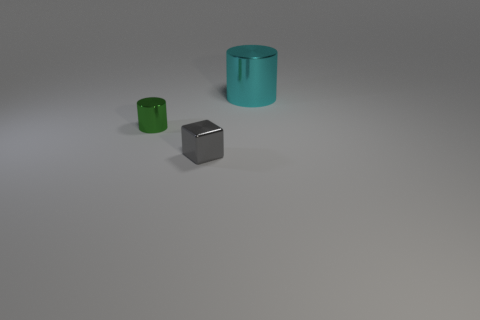Add 1 tiny shiny objects. How many objects exist? 4 Subtract all blocks. How many objects are left? 2 Add 1 brown rubber blocks. How many brown rubber blocks exist? 1 Subtract 0 green blocks. How many objects are left? 3 Subtract all small shiny cubes. Subtract all cyan cylinders. How many objects are left? 1 Add 3 tiny green cylinders. How many tiny green cylinders are left? 4 